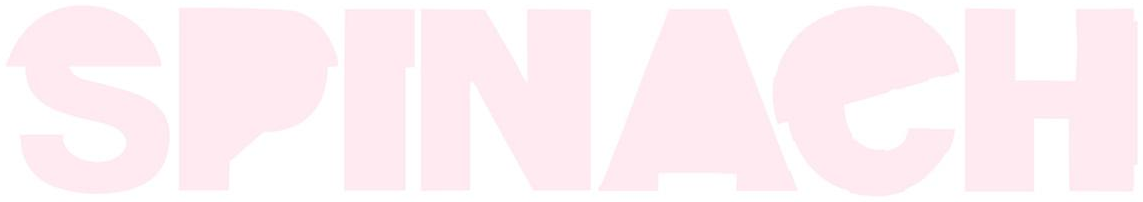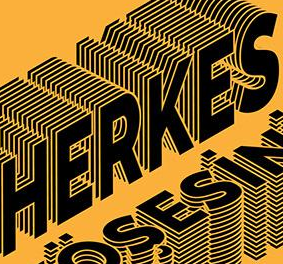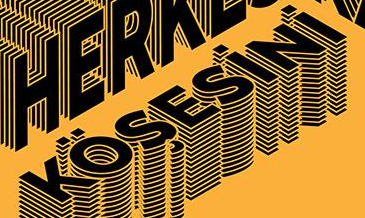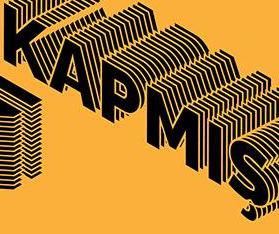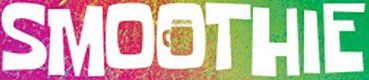What text appears in these images from left to right, separated by a semicolon? SPINAeH; HERKES; KÖŞESiNi; KAPMIŞ; SMOOTHIE 